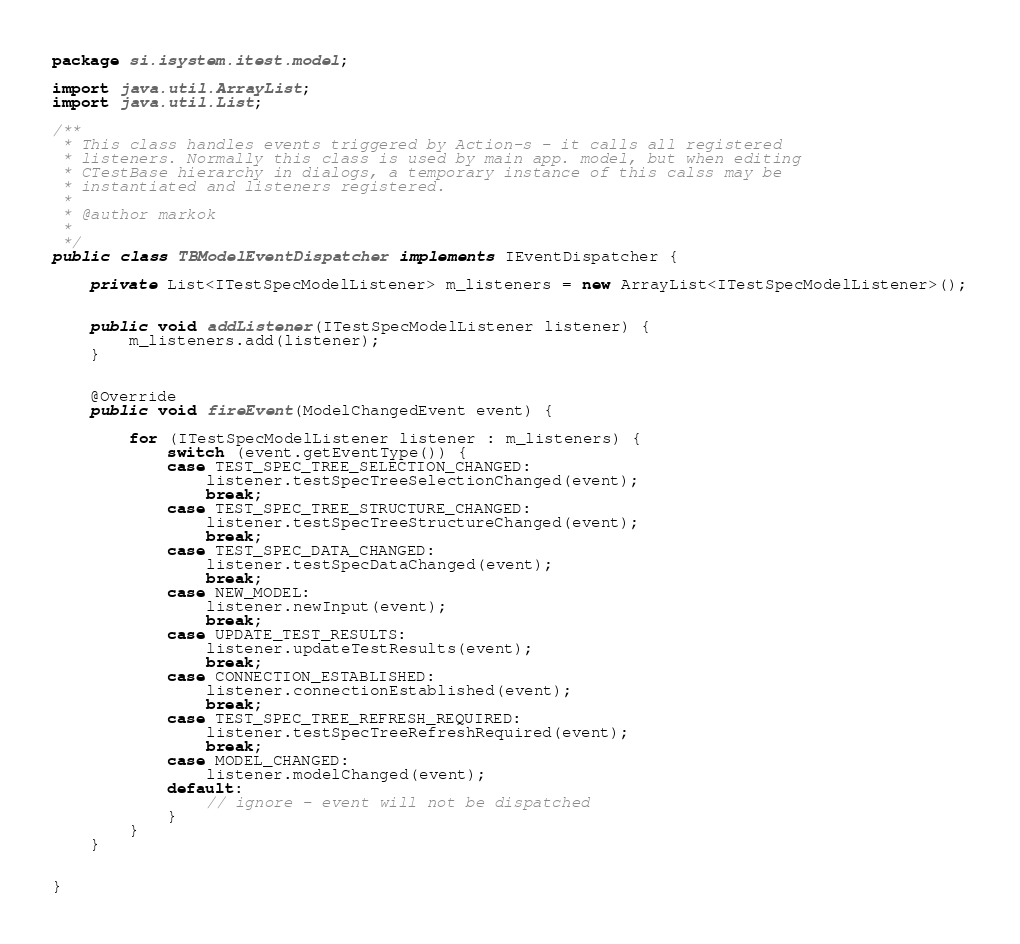<code> <loc_0><loc_0><loc_500><loc_500><_Java_>package si.isystem.itest.model;

import java.util.ArrayList;
import java.util.List;

/**
 * This class handles events triggered by Action-s - it calls all registered 
 * listeners. Normally this class is used by main app. model, but when editing
 * CTestBase hierarchy in dialogs, a temporary instance of this calss may be 
 * instantiated and listeners registered. 
 * 
 * @author markok
 *
 */
public class TBModelEventDispatcher implements IEventDispatcher {

    private List<ITestSpecModelListener> m_listeners = new ArrayList<ITestSpecModelListener>();

    
    public void addListener(ITestSpecModelListener listener) {
        m_listeners.add(listener);
    }

    
    @Override
    public void fireEvent(ModelChangedEvent event) {

        for (ITestSpecModelListener listener : m_listeners) {
            switch (event.getEventType()) {
            case TEST_SPEC_TREE_SELECTION_CHANGED:
                listener.testSpecTreeSelectionChanged(event);
                break;
            case TEST_SPEC_TREE_STRUCTURE_CHANGED:
                listener.testSpecTreeStructureChanged(event);
                break;
            case TEST_SPEC_DATA_CHANGED:
                listener.testSpecDataChanged(event);
                break;
            case NEW_MODEL:
                listener.newInput(event);
                break;
            case UPDATE_TEST_RESULTS:
                listener.updateTestResults(event);
                break;
            case CONNECTION_ESTABLISHED:
                listener.connectionEstablished(event);
                break;
            case TEST_SPEC_TREE_REFRESH_REQUIRED:
                listener.testSpecTreeRefreshRequired(event);
                break;
            case MODEL_CHANGED:
                listener.modelChanged(event);
            default:
                // ignore - event will not be dispatched
            }
        }
    }


}
</code> 